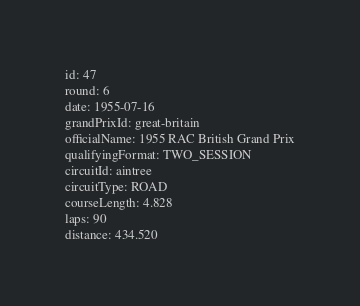<code> <loc_0><loc_0><loc_500><loc_500><_YAML_>id: 47
round: 6
date: 1955-07-16
grandPrixId: great-britain
officialName: 1955 RAC British Grand Prix
qualifyingFormat: TWO_SESSION
circuitId: aintree
circuitType: ROAD
courseLength: 4.828
laps: 90
distance: 434.520
</code> 